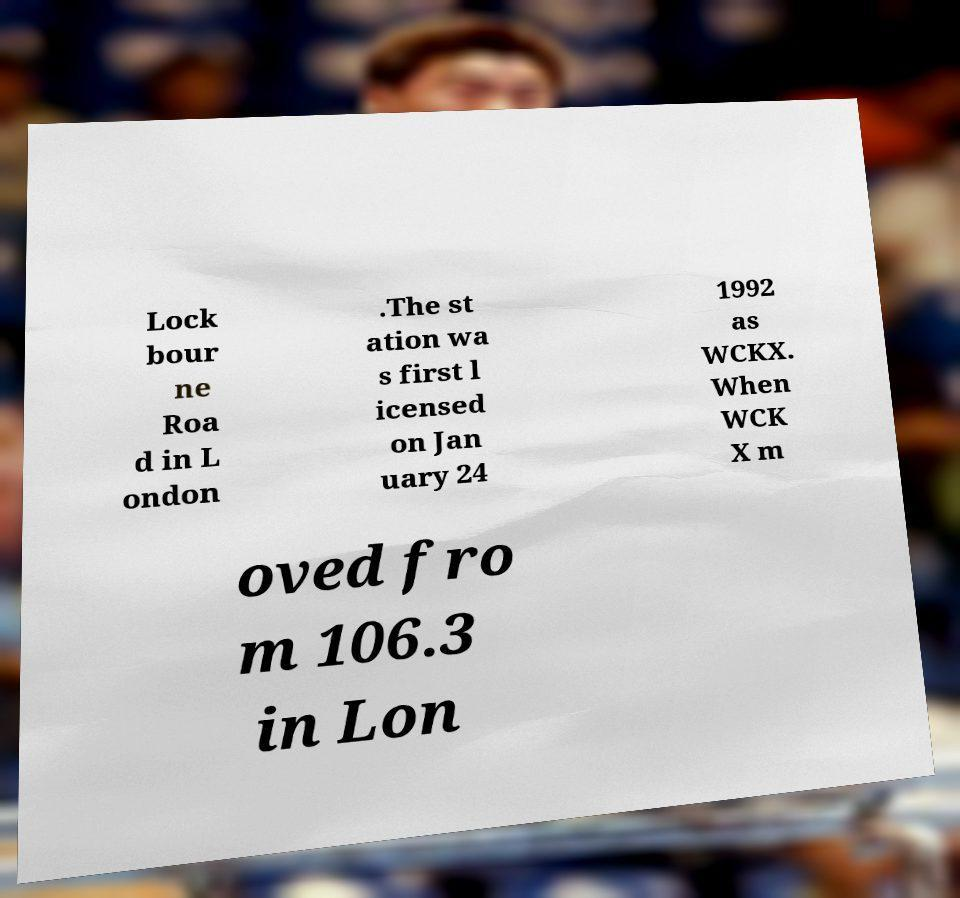Can you read and provide the text displayed in the image?This photo seems to have some interesting text. Can you extract and type it out for me? Lock bour ne Roa d in L ondon .The st ation wa s first l icensed on Jan uary 24 1992 as WCKX. When WCK X m oved fro m 106.3 in Lon 